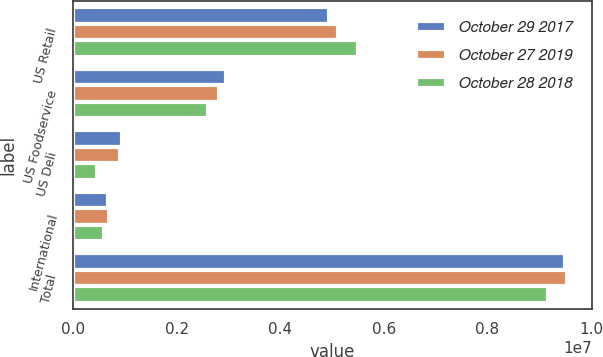Convert chart. <chart><loc_0><loc_0><loc_500><loc_500><stacked_bar_chart><ecel><fcel>US Retail<fcel>US Foodservice<fcel>US Deli<fcel>International<fcel>Total<nl><fcel>October 29 2017<fcel>4.9474e+06<fcel>2.94335e+06<fcel>939069<fcel>667498<fcel>9.49732e+06<nl><fcel>October 27 2019<fcel>5.11299e+06<fcel>2.82495e+06<fcel>914009<fcel>693752<fcel>9.5457e+06<nl><fcel>October 28 2018<fcel>5.49282e+06<fcel>2.61122e+06<fcel>460250<fcel>603226<fcel>9.16752e+06<nl></chart> 